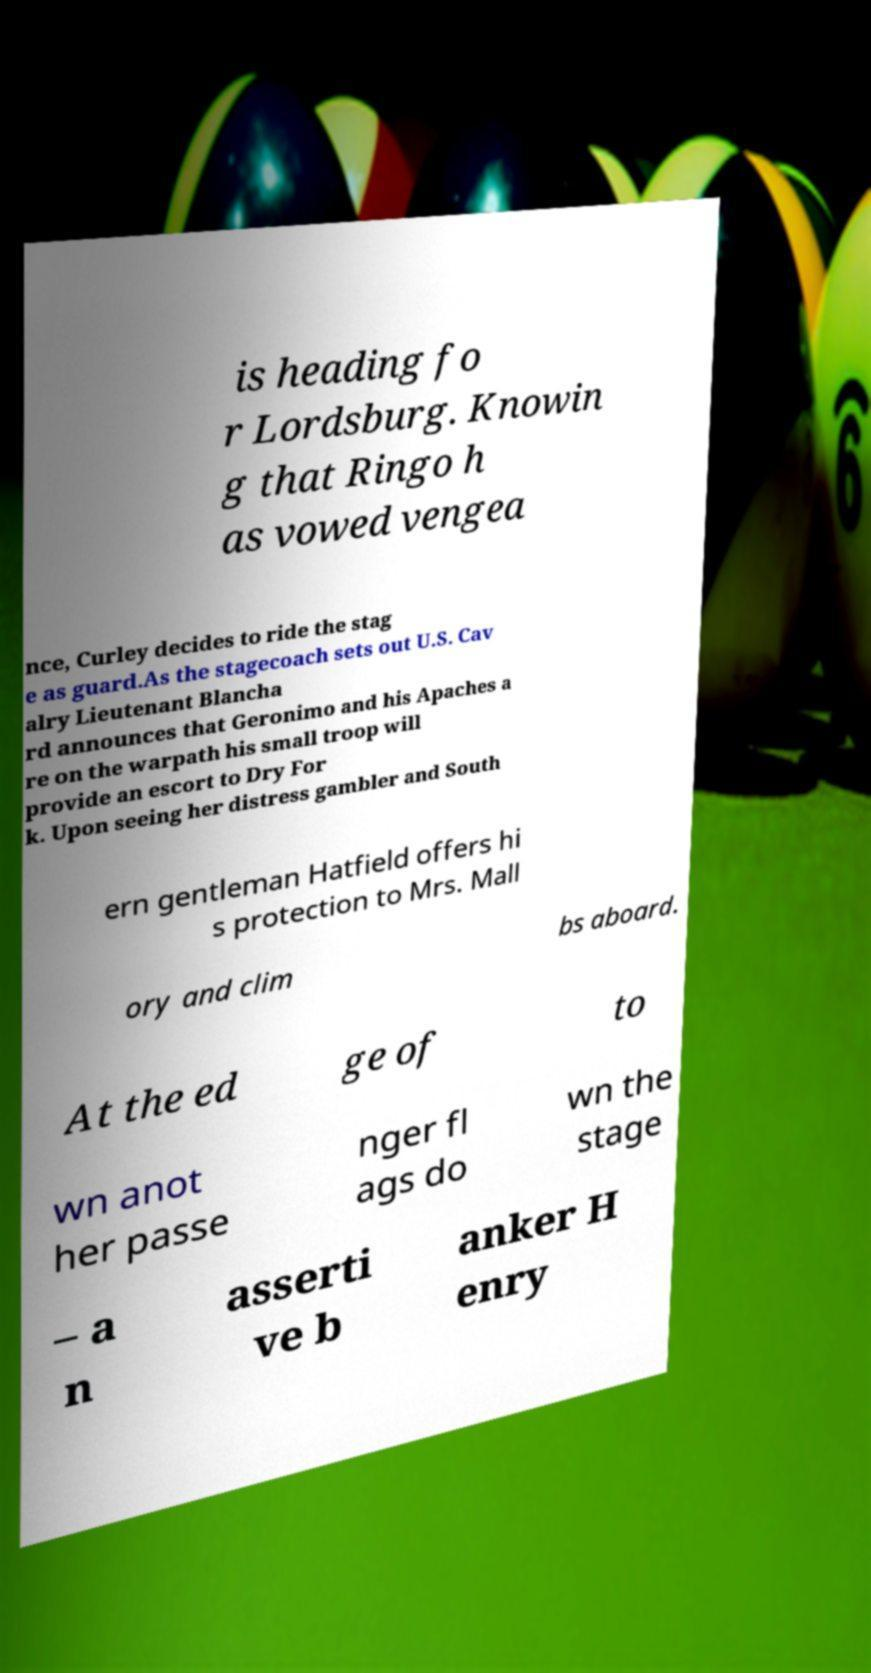Can you accurately transcribe the text from the provided image for me? is heading fo r Lordsburg. Knowin g that Ringo h as vowed vengea nce, Curley decides to ride the stag e as guard.As the stagecoach sets out U.S. Cav alry Lieutenant Blancha rd announces that Geronimo and his Apaches a re on the warpath his small troop will provide an escort to Dry For k. Upon seeing her distress gambler and South ern gentleman Hatfield offers hi s protection to Mrs. Mall ory and clim bs aboard. At the ed ge of to wn anot her passe nger fl ags do wn the stage – a n asserti ve b anker H enry 